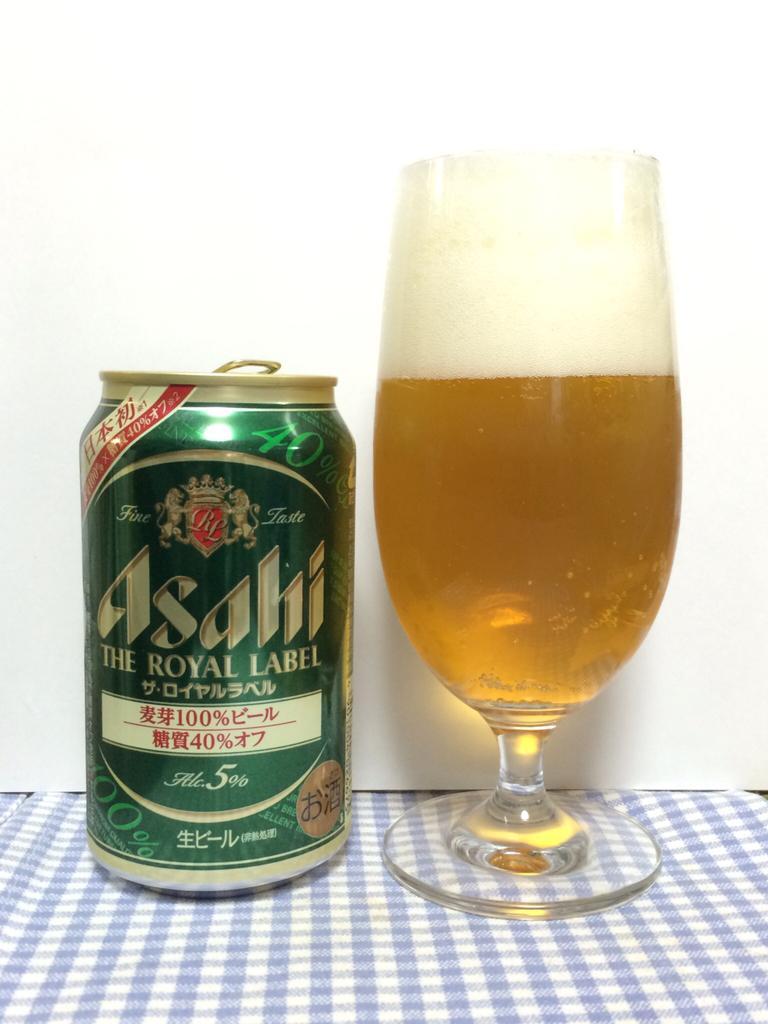Please provide a concise description of this image. In this image there is a drink can. There is text on the drink can. Beside the drink can there is a wine glass. There is drink in the wine glass. Below them there is a cloth. Behind them there is a wall. 